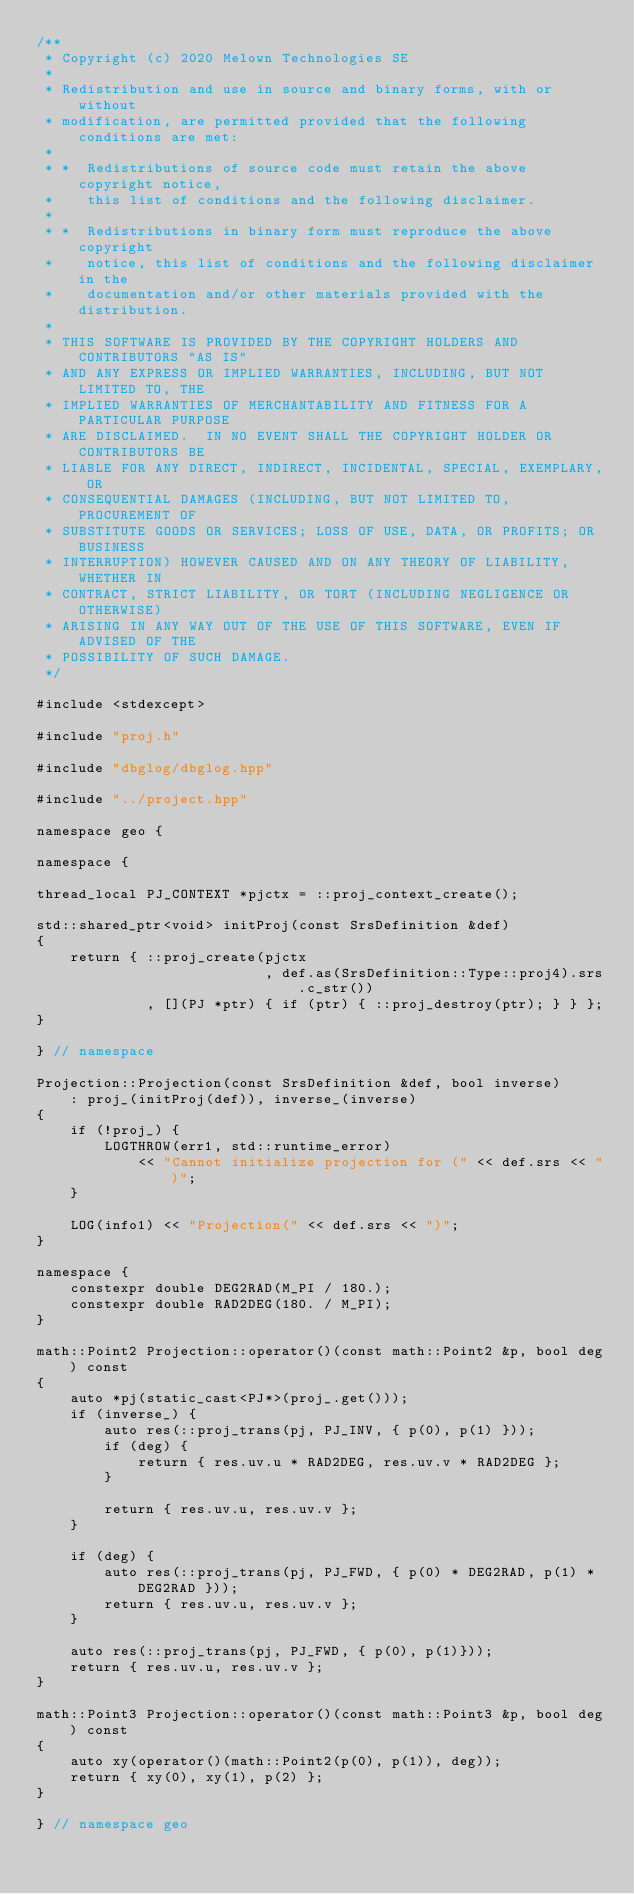<code> <loc_0><loc_0><loc_500><loc_500><_C++_>/**
 * Copyright (c) 2020 Melown Technologies SE
 *
 * Redistribution and use in source and binary forms, with or without
 * modification, are permitted provided that the following conditions are met:
 *
 * *  Redistributions of source code must retain the above copyright notice,
 *    this list of conditions and the following disclaimer.
 *
 * *  Redistributions in binary form must reproduce the above copyright
 *    notice, this list of conditions and the following disclaimer in the
 *    documentation and/or other materials provided with the distribution.
 *
 * THIS SOFTWARE IS PROVIDED BY THE COPYRIGHT HOLDERS AND CONTRIBUTORS "AS IS"
 * AND ANY EXPRESS OR IMPLIED WARRANTIES, INCLUDING, BUT NOT LIMITED TO, THE
 * IMPLIED WARRANTIES OF MERCHANTABILITY AND FITNESS FOR A PARTICULAR PURPOSE
 * ARE DISCLAIMED.  IN NO EVENT SHALL THE COPYRIGHT HOLDER OR CONTRIBUTORS BE
 * LIABLE FOR ANY DIRECT, INDIRECT, INCIDENTAL, SPECIAL, EXEMPLARY, OR
 * CONSEQUENTIAL DAMAGES (INCLUDING, BUT NOT LIMITED TO, PROCUREMENT OF
 * SUBSTITUTE GOODS OR SERVICES; LOSS OF USE, DATA, OR PROFITS; OR BUSINESS
 * INTERRUPTION) HOWEVER CAUSED AND ON ANY THEORY OF LIABILITY, WHETHER IN
 * CONTRACT, STRICT LIABILITY, OR TORT (INCLUDING NEGLIGENCE OR OTHERWISE)
 * ARISING IN ANY WAY OUT OF THE USE OF THIS SOFTWARE, EVEN IF ADVISED OF THE
 * POSSIBILITY OF SUCH DAMAGE.
 */

#include <stdexcept>

#include "proj.h"

#include "dbglog/dbglog.hpp"

#include "../project.hpp"

namespace geo {

namespace {

thread_local PJ_CONTEXT *pjctx = ::proj_context_create();

std::shared_ptr<void> initProj(const SrsDefinition &def)
{
    return { ::proj_create(pjctx
                           , def.as(SrsDefinition::Type::proj4).srs.c_str())
             , [](PJ *ptr) { if (ptr) { ::proj_destroy(ptr); } } };
}

} // namespace

Projection::Projection(const SrsDefinition &def, bool inverse)
    : proj_(initProj(def)), inverse_(inverse)
{
    if (!proj_) {
        LOGTHROW(err1, std::runtime_error)
            << "Cannot initialize projection for (" << def.srs << ")";
    }

    LOG(info1) << "Projection(" << def.srs << ")";
}

namespace {
    constexpr double DEG2RAD(M_PI / 180.);
    constexpr double RAD2DEG(180. / M_PI);
}

math::Point2 Projection::operator()(const math::Point2 &p, bool deg) const
{
    auto *pj(static_cast<PJ*>(proj_.get()));
    if (inverse_) {
        auto res(::proj_trans(pj, PJ_INV, { p(0), p(1) }));
        if (deg) {
            return { res.uv.u * RAD2DEG, res.uv.v * RAD2DEG };
        }

        return { res.uv.u, res.uv.v };
    }

    if (deg) {
        auto res(::proj_trans(pj, PJ_FWD, { p(0) * DEG2RAD, p(1) * DEG2RAD }));
        return { res.uv.u, res.uv.v };
    }

    auto res(::proj_trans(pj, PJ_FWD, { p(0), p(1)}));
    return { res.uv.u, res.uv.v };
}

math::Point3 Projection::operator()(const math::Point3 &p, bool deg) const
{
    auto xy(operator()(math::Point2(p(0), p(1)), deg));
    return { xy(0), xy(1), p(2) };
}

} // namespace geo
</code> 